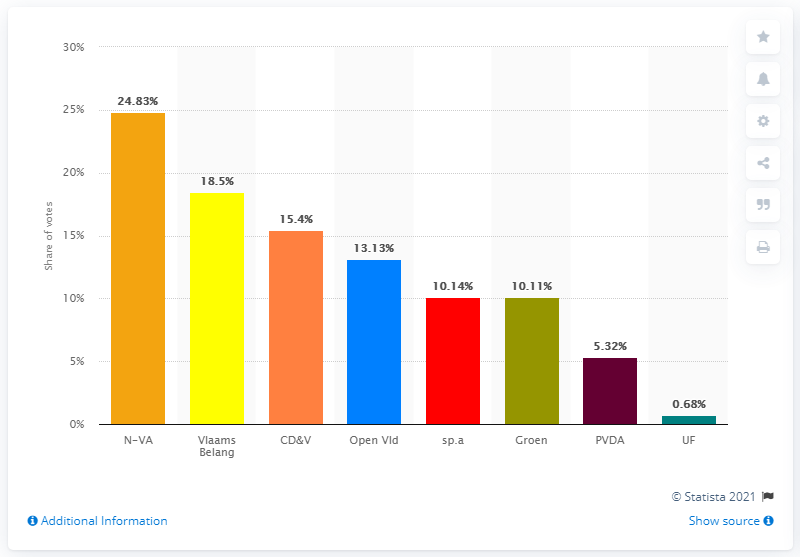Indicate a few pertinent items in this graphic. The name of the Flemish nationalist party is the N-VA. 